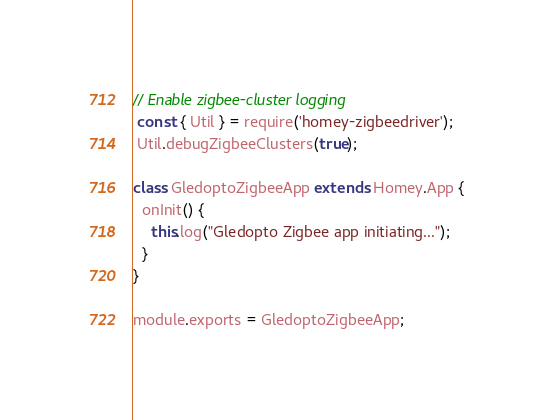Convert code to text. <code><loc_0><loc_0><loc_500><loc_500><_JavaScript_>
// Enable zigbee-cluster logging
 const { Util } = require('homey-zigbeedriver');
 Util.debugZigbeeClusters(true);

class GledoptoZigbeeApp extends Homey.App {
  onInit() {
    this.log("Gledopto Zigbee app initiating...");
  }
}

module.exports = GledoptoZigbeeApp;
</code> 